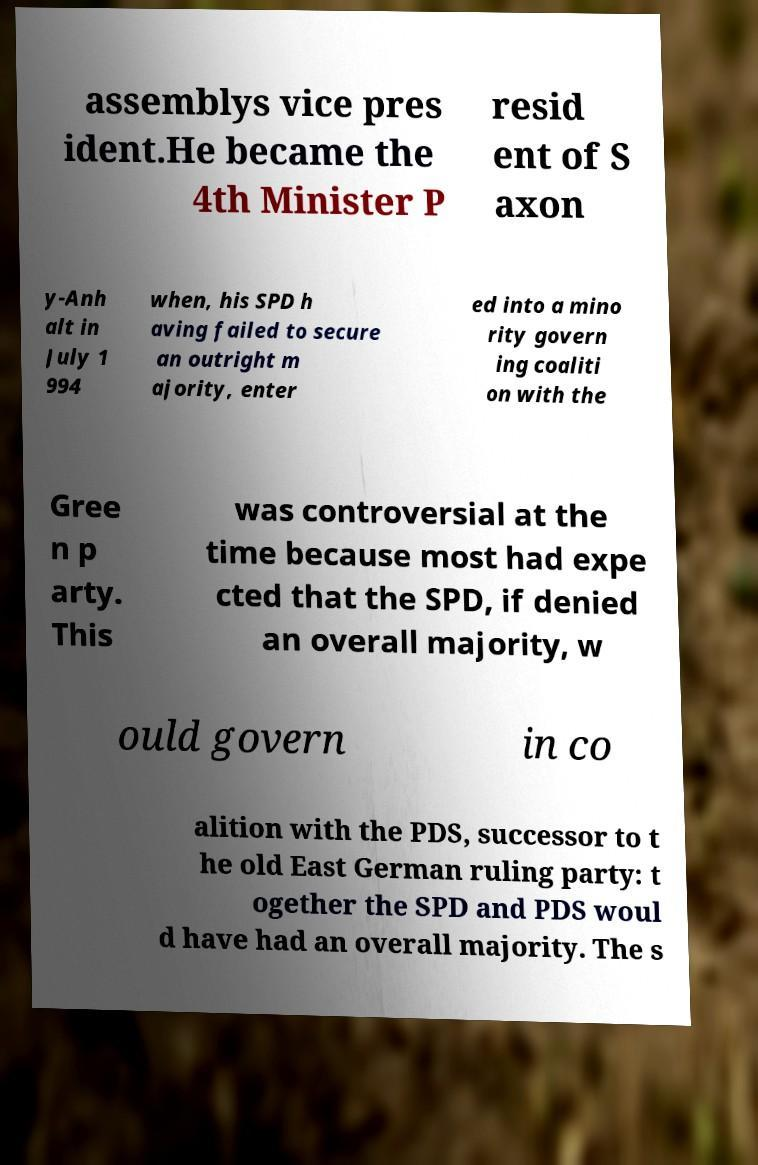Could you extract and type out the text from this image? assemblys vice pres ident.He became the 4th Minister P resid ent of S axon y-Anh alt in July 1 994 when, his SPD h aving failed to secure an outright m ajority, enter ed into a mino rity govern ing coaliti on with the Gree n p arty. This was controversial at the time because most had expe cted that the SPD, if denied an overall majority, w ould govern in co alition with the PDS, successor to t he old East German ruling party: t ogether the SPD and PDS woul d have had an overall majority. The s 